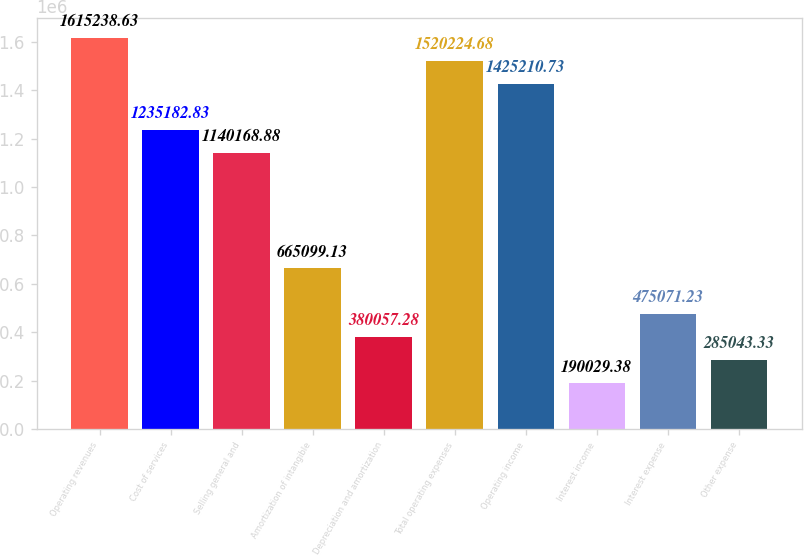<chart> <loc_0><loc_0><loc_500><loc_500><bar_chart><fcel>Operating revenues<fcel>Cost of services<fcel>Selling general and<fcel>Amortization of intangible<fcel>Depreciation and amortization<fcel>Total operating expenses<fcel>Operating income<fcel>Interest income<fcel>Interest expense<fcel>Other expense<nl><fcel>1.61524e+06<fcel>1.23518e+06<fcel>1.14017e+06<fcel>665099<fcel>380057<fcel>1.52022e+06<fcel>1.42521e+06<fcel>190029<fcel>475071<fcel>285043<nl></chart> 